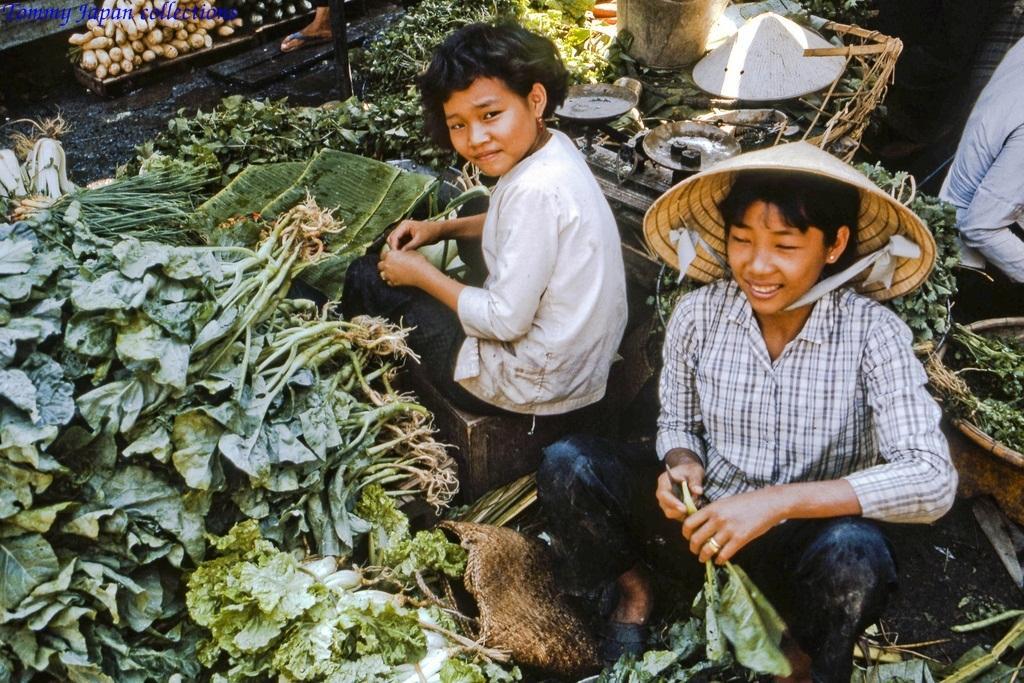In one or two sentences, can you explain what this image depicts? In the image there are two people selling many leafy vegetables and behind them there is a weighing machine and on the right side there is another person behind them. 